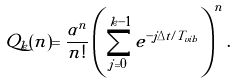<formula> <loc_0><loc_0><loc_500><loc_500>Q _ { k } ( n ) = \frac { \alpha ^ { n } } { n ! } \left ( \sum _ { j = 0 } ^ { k - 1 } e ^ { - j \Delta t / T _ { v i b } } \right ) ^ { n } .</formula> 